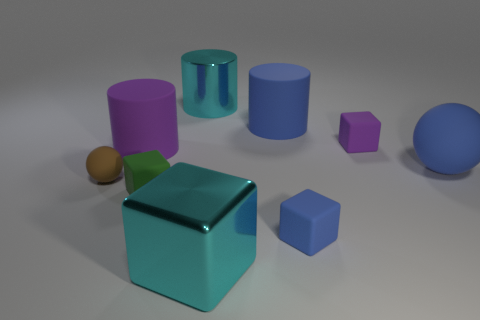What number of other objects are the same material as the green object?
Make the answer very short. 6. There is a object that is in front of the green thing and behind the large cube; what is its shape?
Keep it short and to the point. Cube. How many things are either cyan shiny objects that are behind the brown sphere or matte blocks behind the small green cube?
Your answer should be very brief. 2. Are there an equal number of big cylinders that are behind the cyan metallic cylinder and matte cylinders that are behind the blue cylinder?
Your answer should be compact. Yes. There is a purple thing to the left of the big matte cylinder that is to the right of the large cube; what shape is it?
Your answer should be compact. Cylinder. Are there any other green matte objects of the same shape as the green rubber object?
Provide a succinct answer. No. What number of large shiny spheres are there?
Make the answer very short. 0. Is the small cube to the left of the metal cube made of the same material as the small brown object?
Offer a very short reply. Yes. Are there any gray metallic cylinders that have the same size as the brown sphere?
Your answer should be very brief. No. Do the green rubber thing and the big cyan metallic object that is in front of the tiny green matte block have the same shape?
Your response must be concise. Yes. 